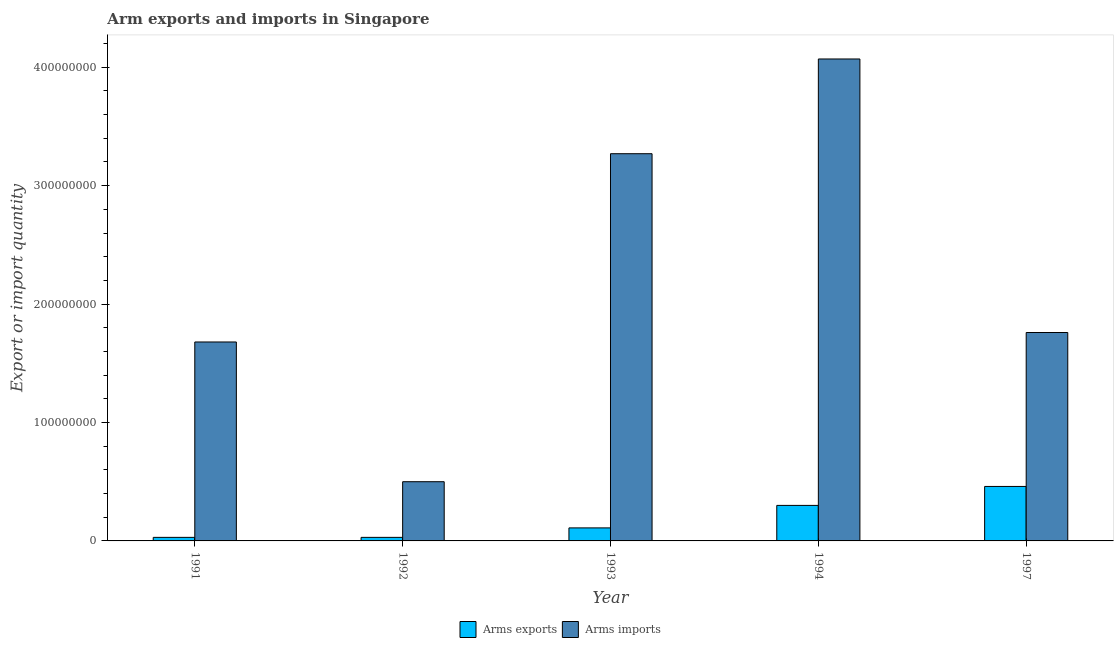What is the label of the 2nd group of bars from the left?
Keep it short and to the point. 1992. In how many cases, is the number of bars for a given year not equal to the number of legend labels?
Provide a short and direct response. 0. What is the arms imports in 1993?
Ensure brevity in your answer.  3.27e+08. Across all years, what is the maximum arms exports?
Offer a very short reply. 4.60e+07. Across all years, what is the minimum arms exports?
Keep it short and to the point. 3.00e+06. In which year was the arms exports maximum?
Offer a very short reply. 1997. What is the total arms imports in the graph?
Provide a succinct answer. 1.13e+09. What is the difference between the arms exports in 1992 and that in 1997?
Offer a terse response. -4.30e+07. What is the difference between the arms exports in 1992 and the arms imports in 1993?
Your response must be concise. -8.00e+06. What is the average arms imports per year?
Make the answer very short. 2.26e+08. In how many years, is the arms exports greater than 240000000?
Give a very brief answer. 0. What is the ratio of the arms imports in 1994 to that in 1997?
Your answer should be very brief. 2.31. Is the arms exports in 1994 less than that in 1997?
Make the answer very short. Yes. What is the difference between the highest and the second highest arms exports?
Make the answer very short. 1.60e+07. What is the difference between the highest and the lowest arms imports?
Your answer should be very brief. 3.57e+08. What does the 2nd bar from the left in 1997 represents?
Your answer should be very brief. Arms imports. What does the 2nd bar from the right in 1992 represents?
Ensure brevity in your answer.  Arms exports. How many bars are there?
Make the answer very short. 10. Are all the bars in the graph horizontal?
Offer a terse response. No. Does the graph contain any zero values?
Keep it short and to the point. No. Where does the legend appear in the graph?
Offer a terse response. Bottom center. How many legend labels are there?
Offer a very short reply. 2. How are the legend labels stacked?
Your response must be concise. Horizontal. What is the title of the graph?
Offer a terse response. Arm exports and imports in Singapore. What is the label or title of the Y-axis?
Keep it short and to the point. Export or import quantity. What is the Export or import quantity in Arms exports in 1991?
Your response must be concise. 3.00e+06. What is the Export or import quantity in Arms imports in 1991?
Keep it short and to the point. 1.68e+08. What is the Export or import quantity in Arms exports in 1992?
Offer a terse response. 3.00e+06. What is the Export or import quantity in Arms exports in 1993?
Provide a short and direct response. 1.10e+07. What is the Export or import quantity in Arms imports in 1993?
Provide a short and direct response. 3.27e+08. What is the Export or import quantity in Arms exports in 1994?
Provide a succinct answer. 3.00e+07. What is the Export or import quantity in Arms imports in 1994?
Your answer should be very brief. 4.07e+08. What is the Export or import quantity of Arms exports in 1997?
Make the answer very short. 4.60e+07. What is the Export or import quantity in Arms imports in 1997?
Your response must be concise. 1.76e+08. Across all years, what is the maximum Export or import quantity in Arms exports?
Your response must be concise. 4.60e+07. Across all years, what is the maximum Export or import quantity of Arms imports?
Offer a terse response. 4.07e+08. Across all years, what is the minimum Export or import quantity in Arms exports?
Your response must be concise. 3.00e+06. What is the total Export or import quantity in Arms exports in the graph?
Ensure brevity in your answer.  9.30e+07. What is the total Export or import quantity of Arms imports in the graph?
Ensure brevity in your answer.  1.13e+09. What is the difference between the Export or import quantity of Arms imports in 1991 and that in 1992?
Offer a terse response. 1.18e+08. What is the difference between the Export or import quantity in Arms exports in 1991 and that in 1993?
Give a very brief answer. -8.00e+06. What is the difference between the Export or import quantity in Arms imports in 1991 and that in 1993?
Give a very brief answer. -1.59e+08. What is the difference between the Export or import quantity of Arms exports in 1991 and that in 1994?
Provide a succinct answer. -2.70e+07. What is the difference between the Export or import quantity in Arms imports in 1991 and that in 1994?
Make the answer very short. -2.39e+08. What is the difference between the Export or import quantity of Arms exports in 1991 and that in 1997?
Offer a terse response. -4.30e+07. What is the difference between the Export or import quantity in Arms imports in 1991 and that in 1997?
Your answer should be very brief. -8.00e+06. What is the difference between the Export or import quantity of Arms exports in 1992 and that in 1993?
Your response must be concise. -8.00e+06. What is the difference between the Export or import quantity of Arms imports in 1992 and that in 1993?
Your response must be concise. -2.77e+08. What is the difference between the Export or import quantity of Arms exports in 1992 and that in 1994?
Your answer should be compact. -2.70e+07. What is the difference between the Export or import quantity in Arms imports in 1992 and that in 1994?
Make the answer very short. -3.57e+08. What is the difference between the Export or import quantity of Arms exports in 1992 and that in 1997?
Provide a succinct answer. -4.30e+07. What is the difference between the Export or import quantity of Arms imports in 1992 and that in 1997?
Offer a terse response. -1.26e+08. What is the difference between the Export or import quantity of Arms exports in 1993 and that in 1994?
Offer a terse response. -1.90e+07. What is the difference between the Export or import quantity of Arms imports in 1993 and that in 1994?
Ensure brevity in your answer.  -8.00e+07. What is the difference between the Export or import quantity in Arms exports in 1993 and that in 1997?
Provide a succinct answer. -3.50e+07. What is the difference between the Export or import quantity of Arms imports in 1993 and that in 1997?
Offer a terse response. 1.51e+08. What is the difference between the Export or import quantity of Arms exports in 1994 and that in 1997?
Make the answer very short. -1.60e+07. What is the difference between the Export or import quantity in Arms imports in 1994 and that in 1997?
Offer a terse response. 2.31e+08. What is the difference between the Export or import quantity in Arms exports in 1991 and the Export or import quantity in Arms imports in 1992?
Provide a succinct answer. -4.70e+07. What is the difference between the Export or import quantity in Arms exports in 1991 and the Export or import quantity in Arms imports in 1993?
Your answer should be very brief. -3.24e+08. What is the difference between the Export or import quantity in Arms exports in 1991 and the Export or import quantity in Arms imports in 1994?
Keep it short and to the point. -4.04e+08. What is the difference between the Export or import quantity of Arms exports in 1991 and the Export or import quantity of Arms imports in 1997?
Make the answer very short. -1.73e+08. What is the difference between the Export or import quantity in Arms exports in 1992 and the Export or import quantity in Arms imports in 1993?
Provide a short and direct response. -3.24e+08. What is the difference between the Export or import quantity of Arms exports in 1992 and the Export or import quantity of Arms imports in 1994?
Ensure brevity in your answer.  -4.04e+08. What is the difference between the Export or import quantity in Arms exports in 1992 and the Export or import quantity in Arms imports in 1997?
Your answer should be compact. -1.73e+08. What is the difference between the Export or import quantity in Arms exports in 1993 and the Export or import quantity in Arms imports in 1994?
Your answer should be very brief. -3.96e+08. What is the difference between the Export or import quantity in Arms exports in 1993 and the Export or import quantity in Arms imports in 1997?
Give a very brief answer. -1.65e+08. What is the difference between the Export or import quantity of Arms exports in 1994 and the Export or import quantity of Arms imports in 1997?
Provide a short and direct response. -1.46e+08. What is the average Export or import quantity of Arms exports per year?
Provide a succinct answer. 1.86e+07. What is the average Export or import quantity of Arms imports per year?
Give a very brief answer. 2.26e+08. In the year 1991, what is the difference between the Export or import quantity in Arms exports and Export or import quantity in Arms imports?
Your response must be concise. -1.65e+08. In the year 1992, what is the difference between the Export or import quantity in Arms exports and Export or import quantity in Arms imports?
Offer a terse response. -4.70e+07. In the year 1993, what is the difference between the Export or import quantity in Arms exports and Export or import quantity in Arms imports?
Provide a short and direct response. -3.16e+08. In the year 1994, what is the difference between the Export or import quantity in Arms exports and Export or import quantity in Arms imports?
Offer a terse response. -3.77e+08. In the year 1997, what is the difference between the Export or import quantity of Arms exports and Export or import quantity of Arms imports?
Offer a very short reply. -1.30e+08. What is the ratio of the Export or import quantity of Arms exports in 1991 to that in 1992?
Give a very brief answer. 1. What is the ratio of the Export or import quantity of Arms imports in 1991 to that in 1992?
Your response must be concise. 3.36. What is the ratio of the Export or import quantity of Arms exports in 1991 to that in 1993?
Offer a terse response. 0.27. What is the ratio of the Export or import quantity of Arms imports in 1991 to that in 1993?
Your answer should be very brief. 0.51. What is the ratio of the Export or import quantity of Arms imports in 1991 to that in 1994?
Make the answer very short. 0.41. What is the ratio of the Export or import quantity of Arms exports in 1991 to that in 1997?
Your answer should be very brief. 0.07. What is the ratio of the Export or import quantity in Arms imports in 1991 to that in 1997?
Offer a very short reply. 0.95. What is the ratio of the Export or import quantity of Arms exports in 1992 to that in 1993?
Provide a succinct answer. 0.27. What is the ratio of the Export or import quantity of Arms imports in 1992 to that in 1993?
Make the answer very short. 0.15. What is the ratio of the Export or import quantity of Arms exports in 1992 to that in 1994?
Ensure brevity in your answer.  0.1. What is the ratio of the Export or import quantity in Arms imports in 1992 to that in 1994?
Ensure brevity in your answer.  0.12. What is the ratio of the Export or import quantity in Arms exports in 1992 to that in 1997?
Ensure brevity in your answer.  0.07. What is the ratio of the Export or import quantity of Arms imports in 1992 to that in 1997?
Your answer should be compact. 0.28. What is the ratio of the Export or import quantity of Arms exports in 1993 to that in 1994?
Provide a short and direct response. 0.37. What is the ratio of the Export or import quantity in Arms imports in 1993 to that in 1994?
Provide a short and direct response. 0.8. What is the ratio of the Export or import quantity in Arms exports in 1993 to that in 1997?
Offer a terse response. 0.24. What is the ratio of the Export or import quantity in Arms imports in 1993 to that in 1997?
Offer a terse response. 1.86. What is the ratio of the Export or import quantity of Arms exports in 1994 to that in 1997?
Your answer should be compact. 0.65. What is the ratio of the Export or import quantity in Arms imports in 1994 to that in 1997?
Your answer should be very brief. 2.31. What is the difference between the highest and the second highest Export or import quantity in Arms exports?
Provide a short and direct response. 1.60e+07. What is the difference between the highest and the second highest Export or import quantity of Arms imports?
Your response must be concise. 8.00e+07. What is the difference between the highest and the lowest Export or import quantity of Arms exports?
Give a very brief answer. 4.30e+07. What is the difference between the highest and the lowest Export or import quantity of Arms imports?
Your answer should be compact. 3.57e+08. 